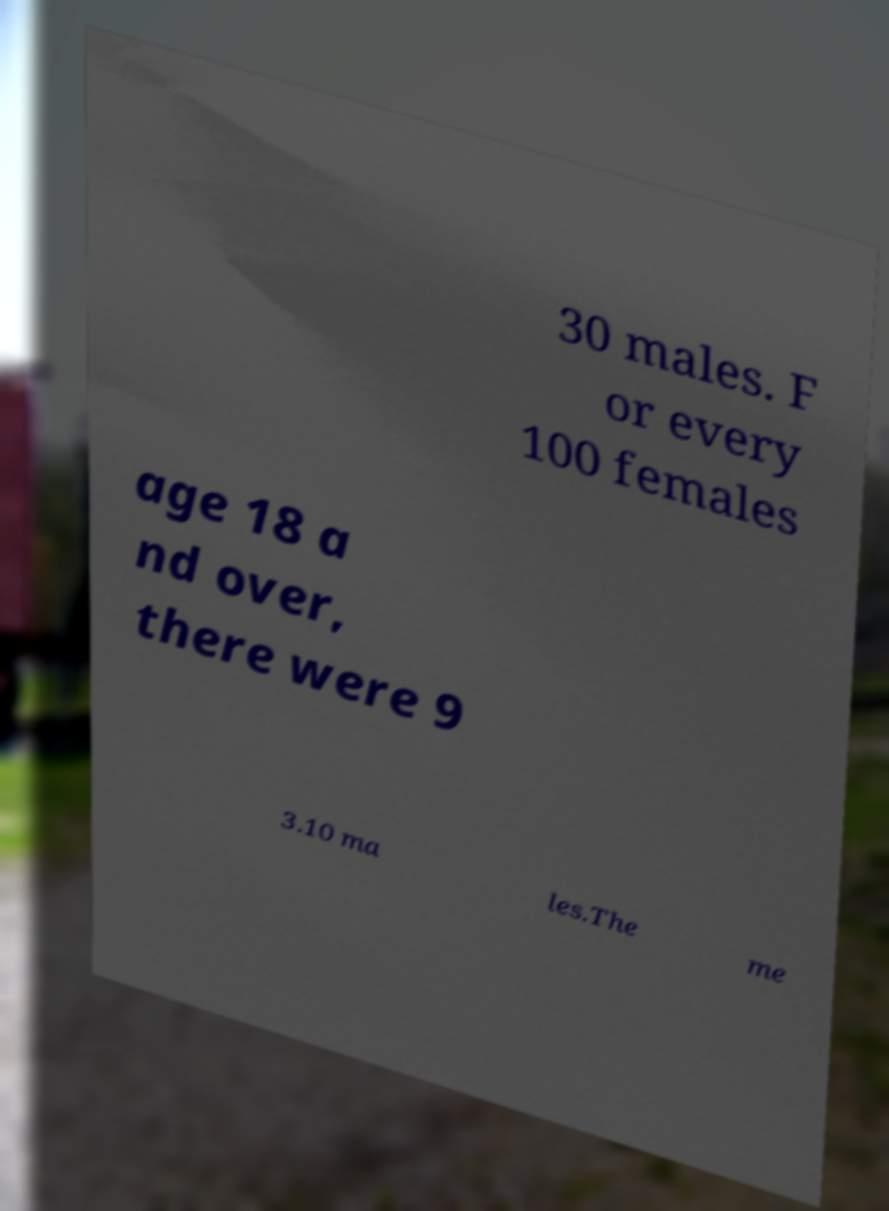Could you assist in decoding the text presented in this image and type it out clearly? 30 males. F or every 100 females age 18 a nd over, there were 9 3.10 ma les.The me 